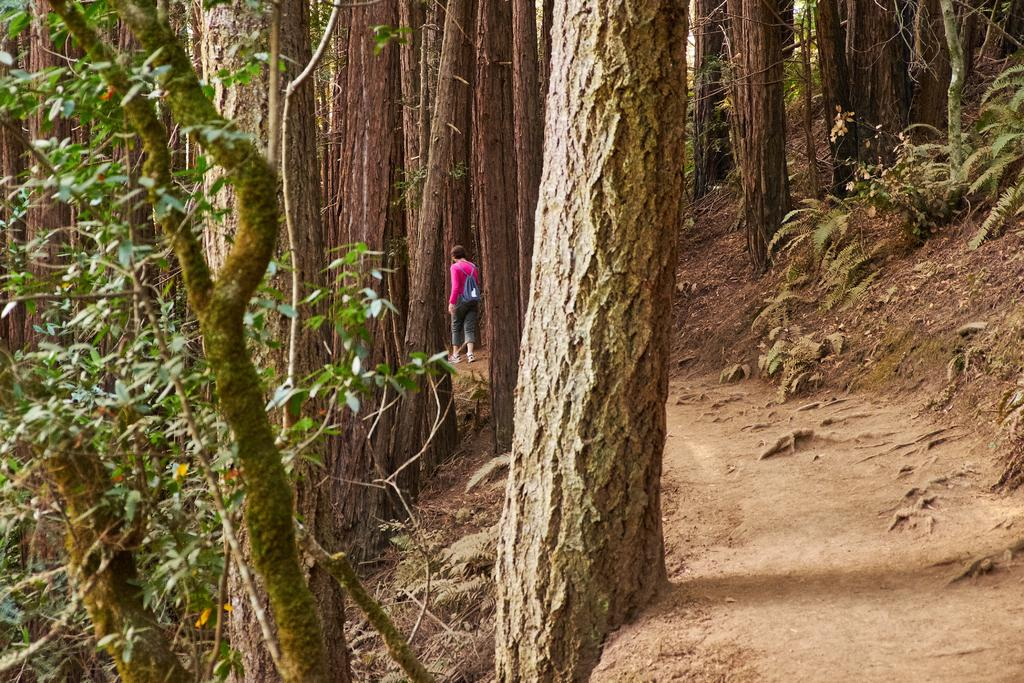Who is present in the image? There is a person in the image. What is the person wearing on their upper body? The person is wearing a pink shirt. What is the person wearing on their lower body? The person is wearing gray pants. What type of bag does the person have? The person has a blue bag. What can be seen in the background of the image? There are trees in the background of the image. What is the color of the trees in the image? The trees are green in color. What is the chance of the person driving a car in the image? There is no information about a car or driving in the image, so it is impossible to determine the chance of the person driving a car. 